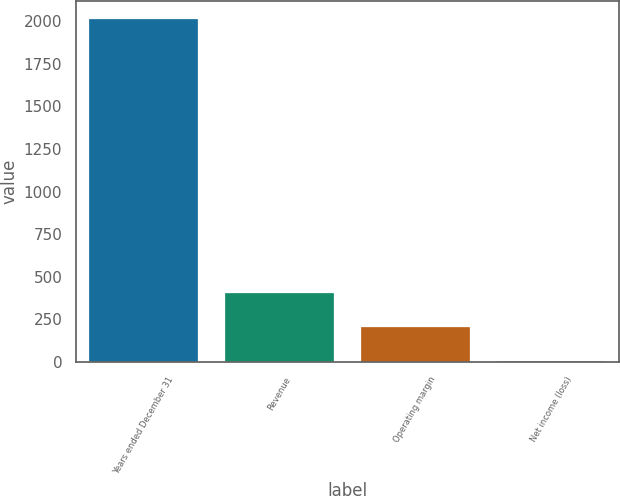<chart> <loc_0><loc_0><loc_500><loc_500><bar_chart><fcel>Years ended December 31<fcel>Revenue<fcel>Operating margin<fcel>Net income (loss)<nl><fcel>2015<fcel>407.8<fcel>206.9<fcel>6<nl></chart> 